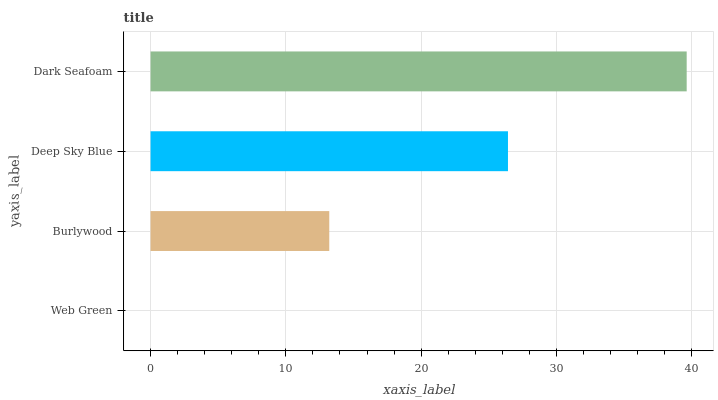Is Web Green the minimum?
Answer yes or no. Yes. Is Dark Seafoam the maximum?
Answer yes or no. Yes. Is Burlywood the minimum?
Answer yes or no. No. Is Burlywood the maximum?
Answer yes or no. No. Is Burlywood greater than Web Green?
Answer yes or no. Yes. Is Web Green less than Burlywood?
Answer yes or no. Yes. Is Web Green greater than Burlywood?
Answer yes or no. No. Is Burlywood less than Web Green?
Answer yes or no. No. Is Deep Sky Blue the high median?
Answer yes or no. Yes. Is Burlywood the low median?
Answer yes or no. Yes. Is Web Green the high median?
Answer yes or no. No. Is Web Green the low median?
Answer yes or no. No. 